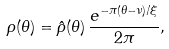<formula> <loc_0><loc_0><loc_500><loc_500>\rho ( \theta ) = \hat { \rho } ( \theta ) \, \frac { e ^ { - \pi ( \theta - \nu ) / \xi } } { 2 \pi } ,</formula> 